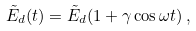<formula> <loc_0><loc_0><loc_500><loc_500>\tilde { E } _ { d } ( t ) = \tilde { E } _ { d } ( 1 + \gamma \cos \omega t ) \, ,</formula> 